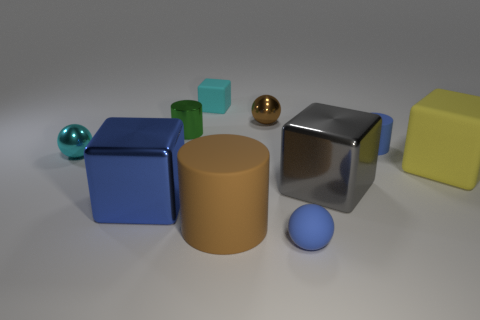How many objects are either yellow matte cubes or cyan blocks?
Your response must be concise. 2. Are there an equal number of large metallic objects that are behind the big blue metallic thing and big blue blocks?
Offer a terse response. Yes. Is there a tiny object left of the small matte object in front of the sphere left of the small cube?
Provide a short and direct response. Yes. The other large cylinder that is the same material as the blue cylinder is what color?
Offer a very short reply. Brown. There is a big block that is left of the large brown cylinder; is it the same color as the small rubber cylinder?
Ensure brevity in your answer.  Yes. How many cylinders are small blue rubber objects or big brown rubber things?
Make the answer very short. 2. There is a brown cylinder to the right of the green metal object behind the cyan thing that is in front of the blue matte cylinder; what is its size?
Make the answer very short. Large. What is the shape of the blue metallic thing that is the same size as the yellow block?
Your response must be concise. Cube. The brown shiny object has what shape?
Make the answer very short. Sphere. Is the cyan thing behind the brown metallic thing made of the same material as the large blue object?
Provide a succinct answer. No. 